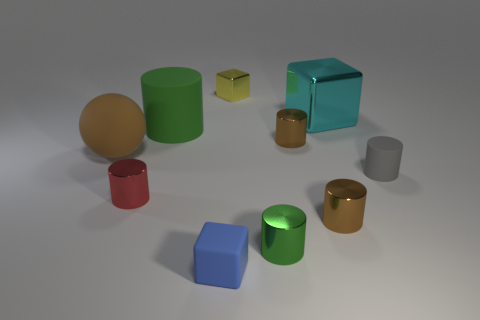Subtract all gray balls. How many brown cylinders are left? 2 Subtract 3 cylinders. How many cylinders are left? 3 Subtract all tiny cubes. How many cubes are left? 1 Subtract all green cylinders. How many cylinders are left? 4 Subtract all balls. How many objects are left? 9 Subtract all green cylinders. Subtract all brown balls. How many cylinders are left? 4 Subtract all large shiny blocks. Subtract all large cyan rubber blocks. How many objects are left? 9 Add 3 yellow shiny objects. How many yellow shiny objects are left? 4 Add 8 cyan metal objects. How many cyan metal objects exist? 9 Subtract 1 brown spheres. How many objects are left? 9 